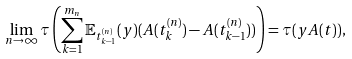<formula> <loc_0><loc_0><loc_500><loc_500>\lim _ { n \to \infty } \tau \left ( \sum _ { k = 1 } ^ { m _ { n } } \mathbb { E } _ { t _ { k - 1 } ^ { ( n ) } } ( y ) ( A ( t _ { k } ^ { ( n ) } ) - A ( t _ { k - 1 } ^ { ( n ) } ) ) \right ) = \tau ( y A ( t ) ) ,</formula> 